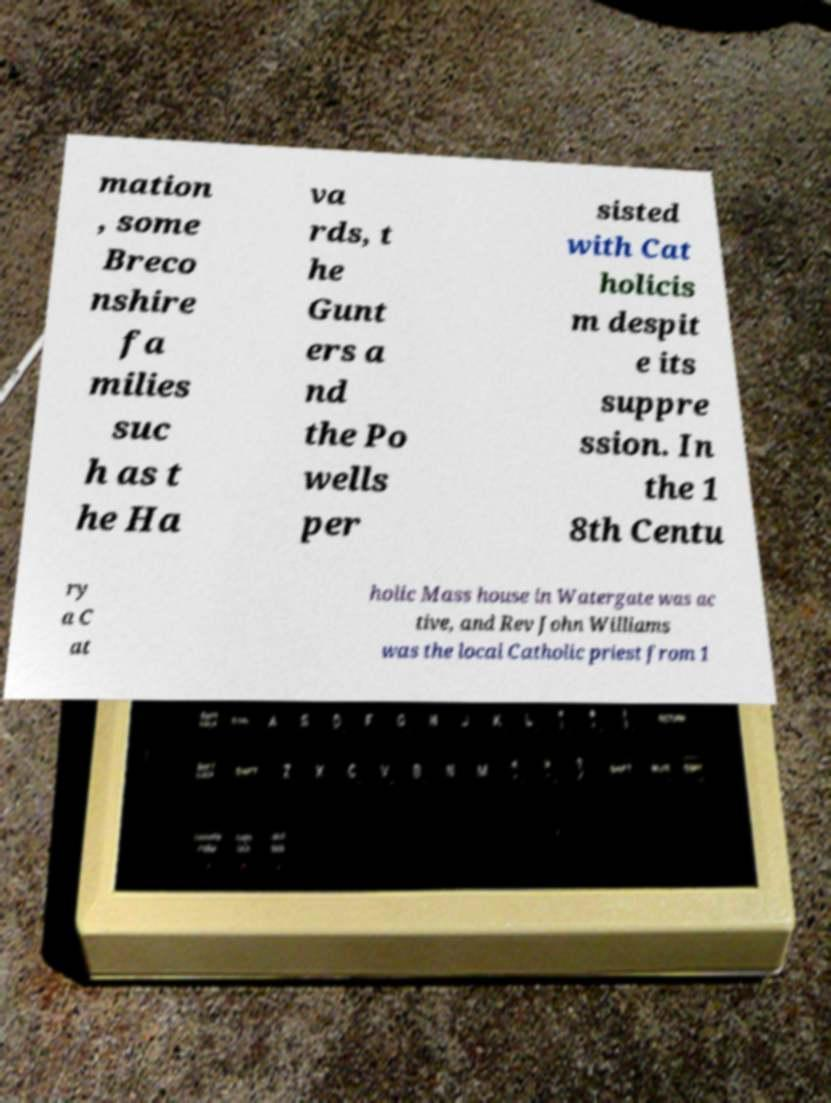What messages or text are displayed in this image? I need them in a readable, typed format. mation , some Breco nshire fa milies suc h as t he Ha va rds, t he Gunt ers a nd the Po wells per sisted with Cat holicis m despit e its suppre ssion. In the 1 8th Centu ry a C at holic Mass house in Watergate was ac tive, and Rev John Williams was the local Catholic priest from 1 